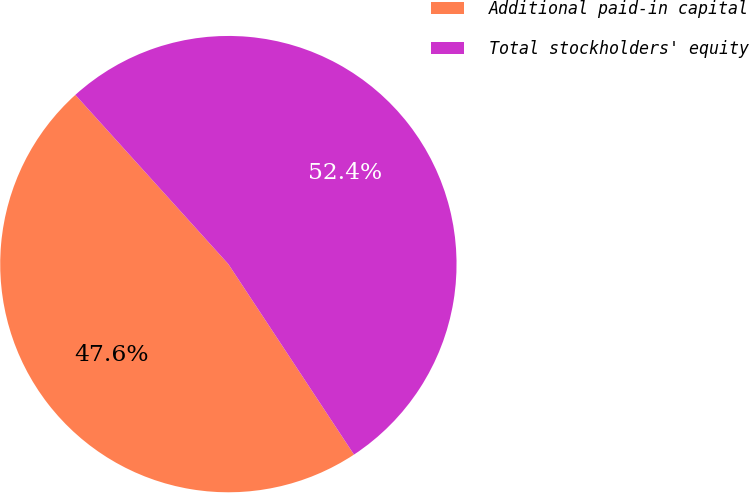Convert chart to OTSL. <chart><loc_0><loc_0><loc_500><loc_500><pie_chart><fcel>Additional paid-in capital<fcel>Total stockholders' equity<nl><fcel>47.58%<fcel>52.42%<nl></chart> 